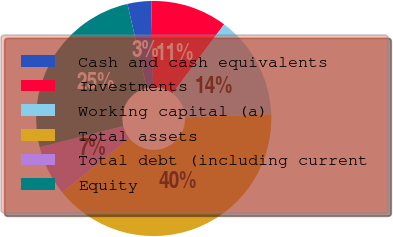Convert chart to OTSL. <chart><loc_0><loc_0><loc_500><loc_500><pie_chart><fcel>Cash and cash equivalents<fcel>Investments<fcel>Working capital (a)<fcel>Total assets<fcel>Total debt (including current<fcel>Equity<nl><fcel>3.26%<fcel>10.55%<fcel>14.2%<fcel>39.75%<fcel>6.9%<fcel>25.33%<nl></chart> 